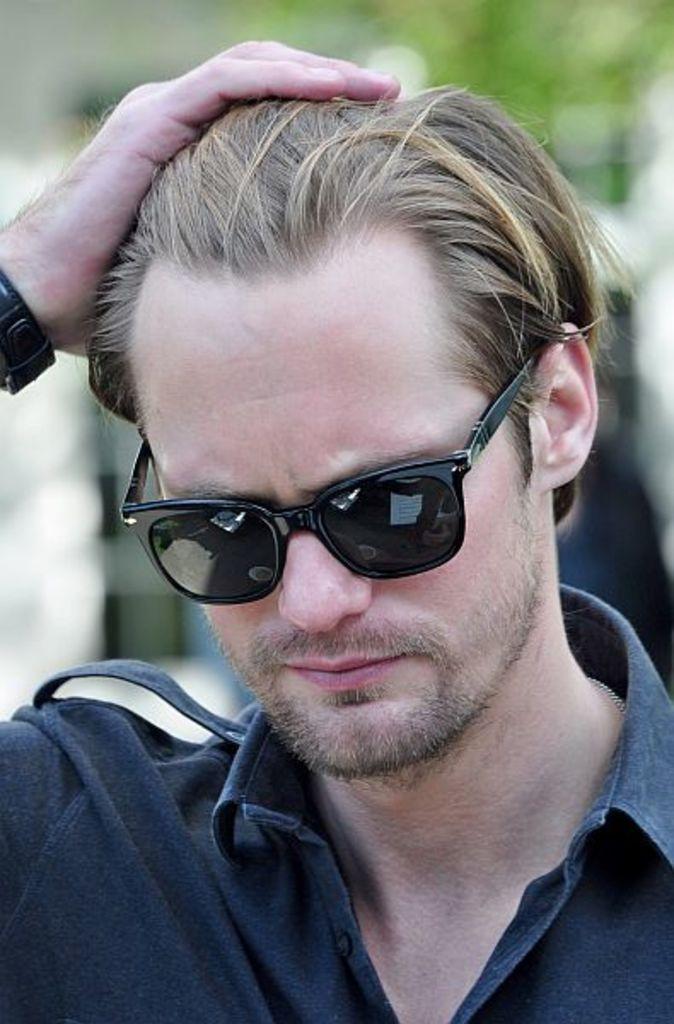In one or two sentences, can you explain what this image depicts? In the picture we can see a man with a blue color shirt and black color goggles and keeping his hand on his hair and behind him we can see a something which are not clearly visible. 